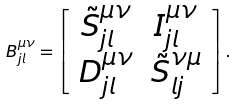Convert formula to latex. <formula><loc_0><loc_0><loc_500><loc_500>B ^ { \mu \nu } _ { j l } = \left [ \begin{array} { c c } { \tilde { S } } ^ { \mu \nu } _ { j l } & I ^ { \mu \nu } _ { j l } \\ D ^ { \mu \nu } _ { j l } & { \tilde { S } } ^ { \nu \mu } _ { l j } \end{array} \right ] .</formula> 